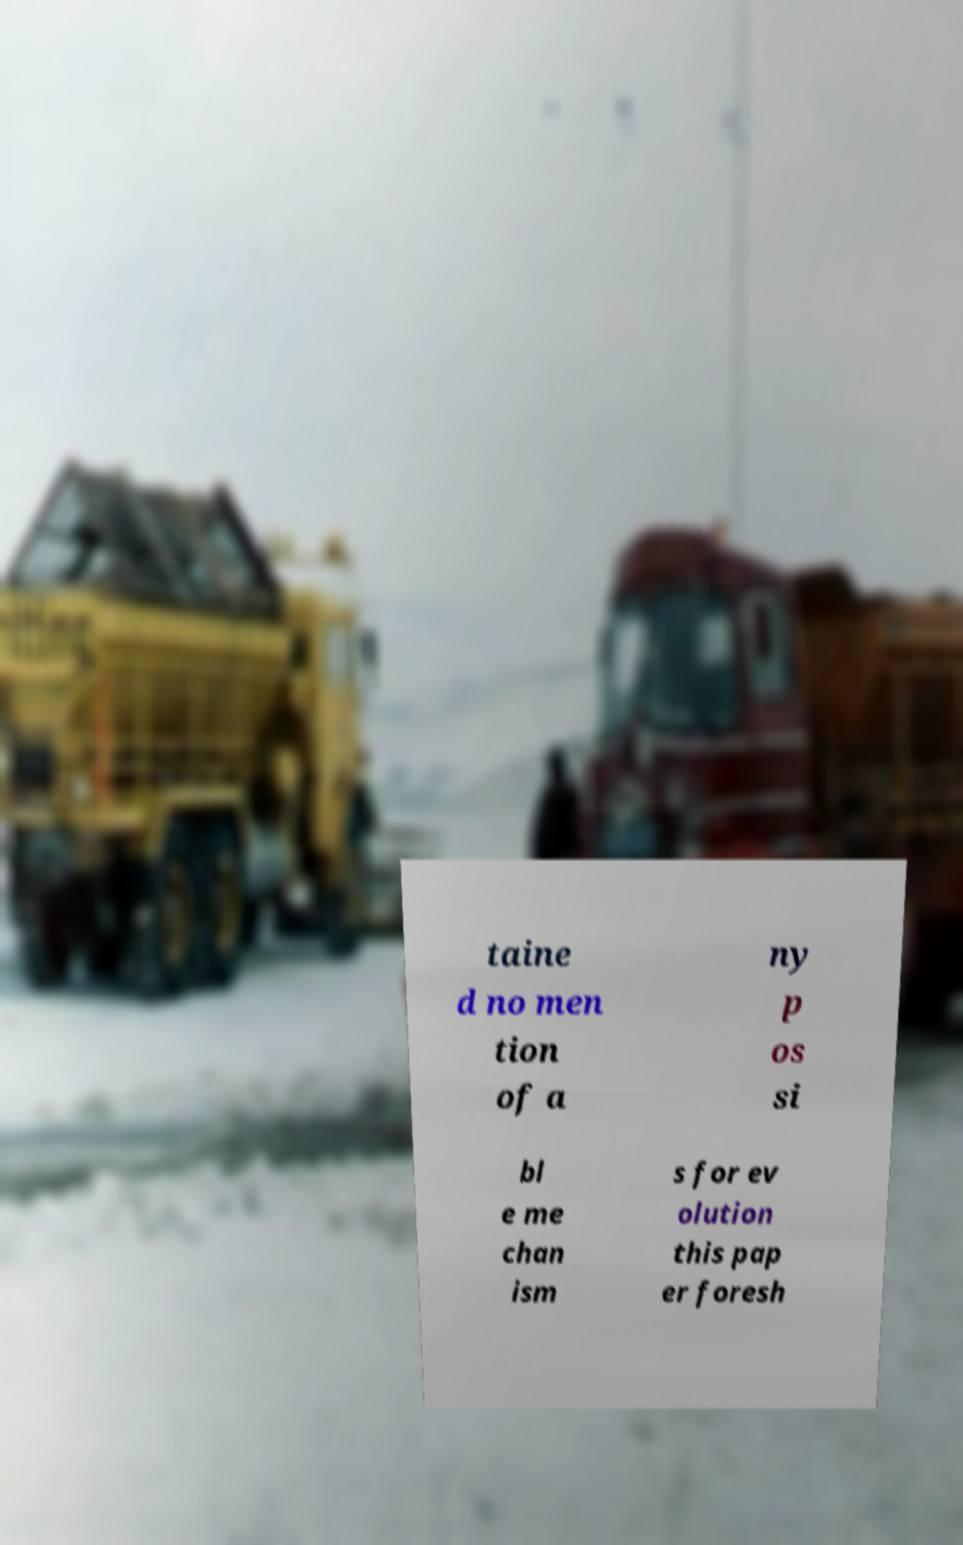I need the written content from this picture converted into text. Can you do that? taine d no men tion of a ny p os si bl e me chan ism s for ev olution this pap er foresh 